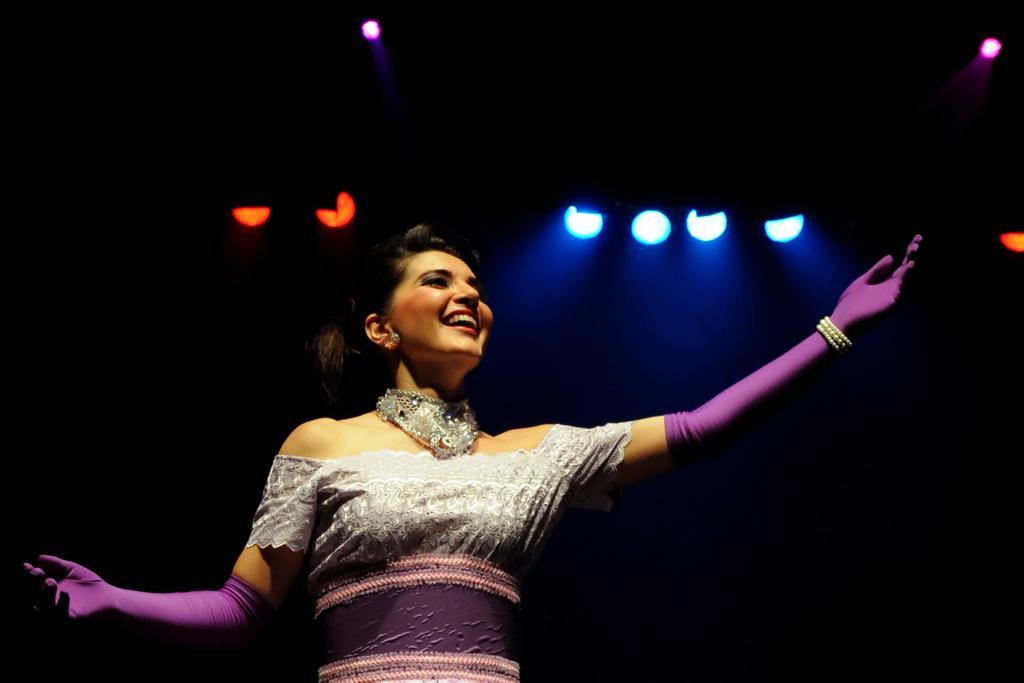In one or two sentences, can you explain what this image depicts? In this picture we can see a woman smiling and in the background we can see the lights and it is dark. 